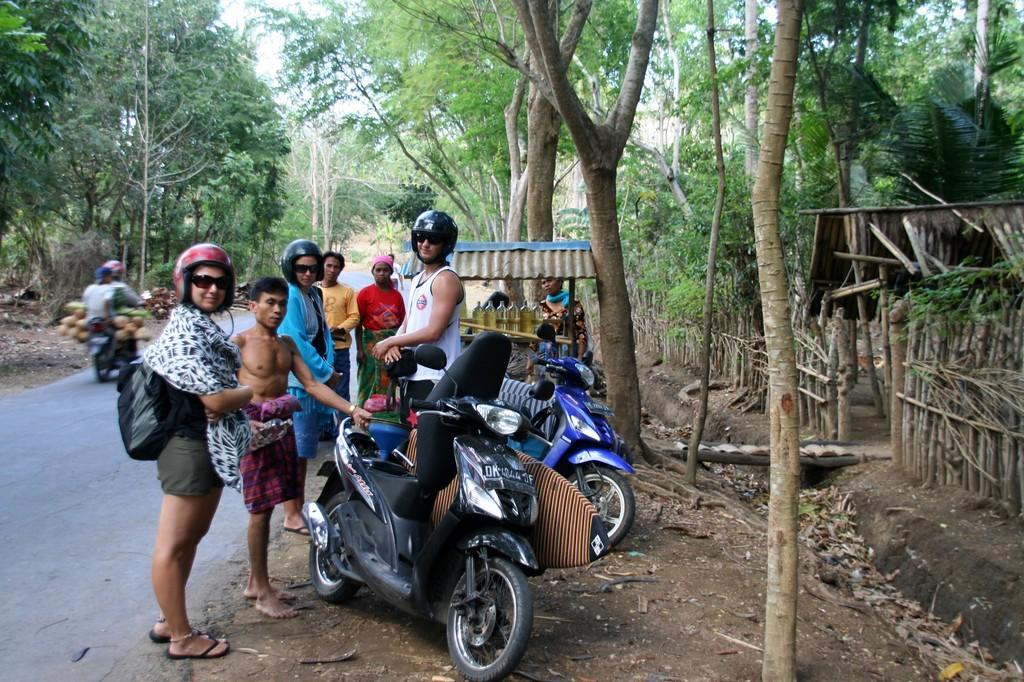What are the people in the image doing? There are persons standing on the road in the image. What objects are in front of the persons? There are two bikes in front of the persons. Can you describe the scene in the background? In the background, there are two other persons on a vehicle and a tree visible. What can be seen above the scene? The sky is visible in the image. What type of wine is being served at the event in the image? There is no event or wine present in the image; it features persons standing on the road with bikes and a scene in the background. 